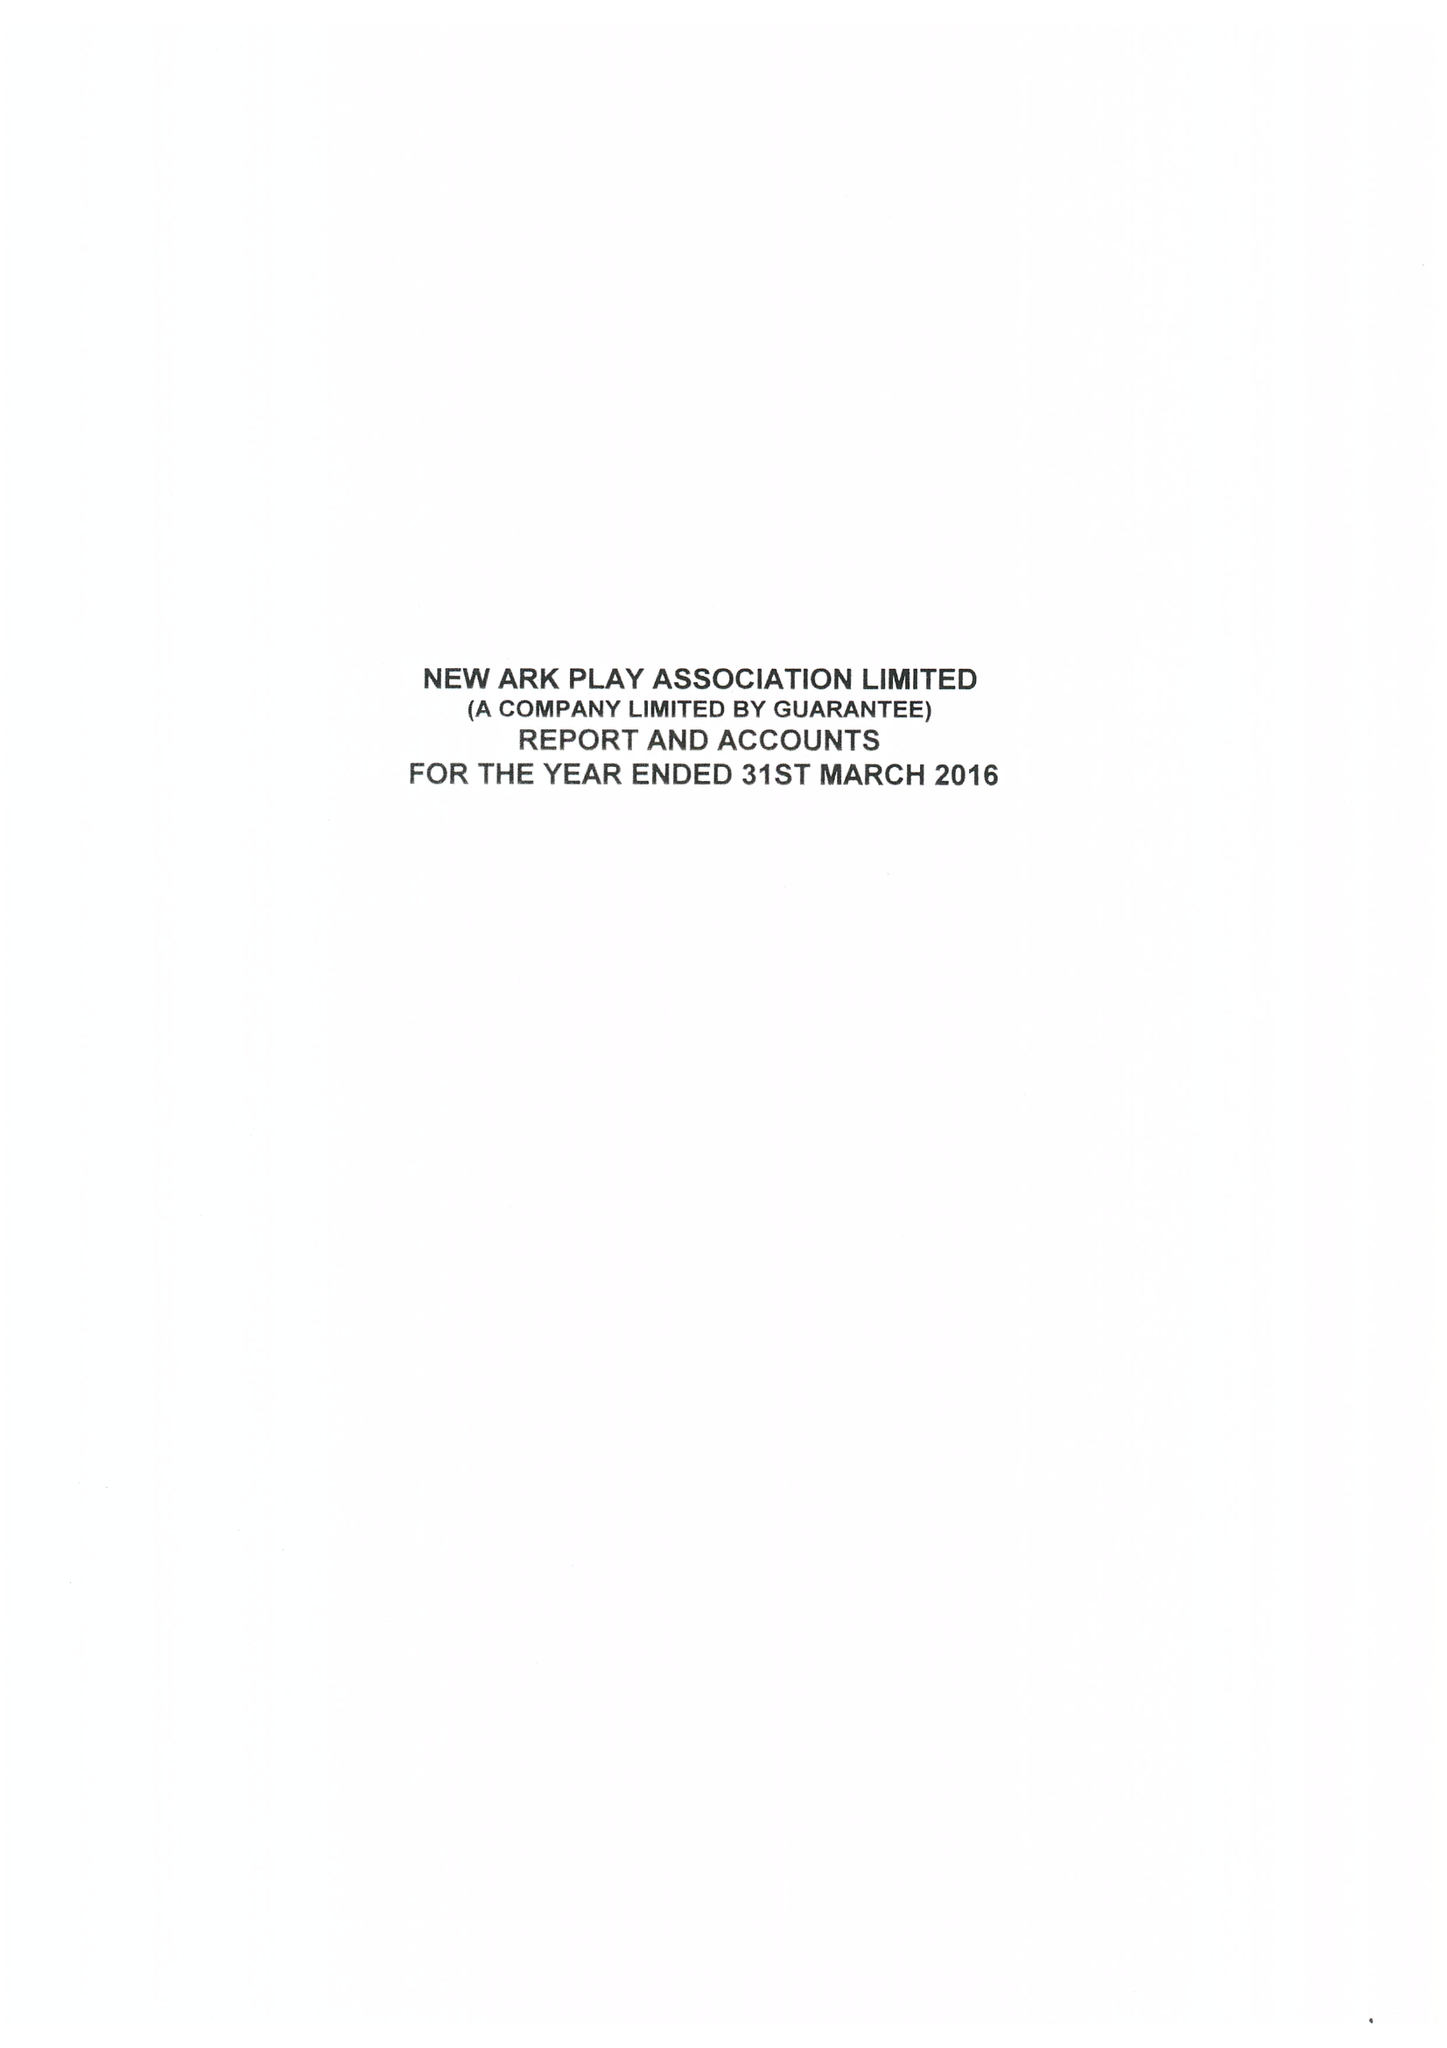What is the value for the charity_name?
Answer the question using a single word or phrase. New Ark Play Association Ltd. 